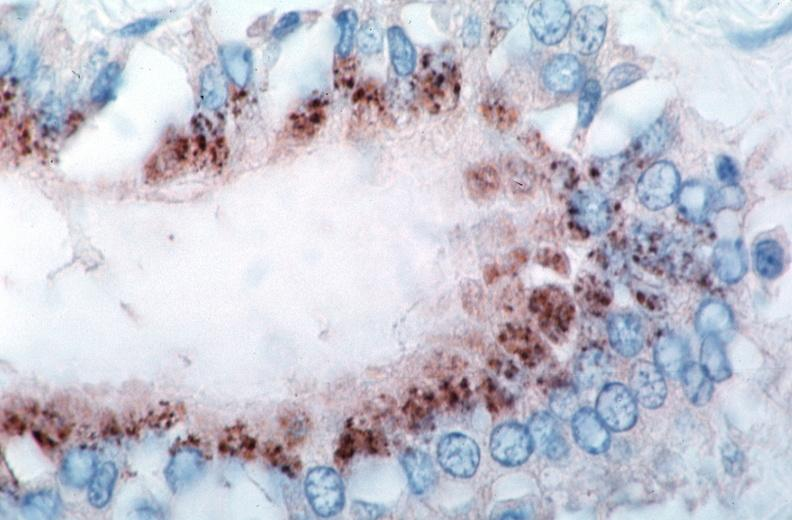what is present?
Answer the question using a single word or phrase. Vasculature 